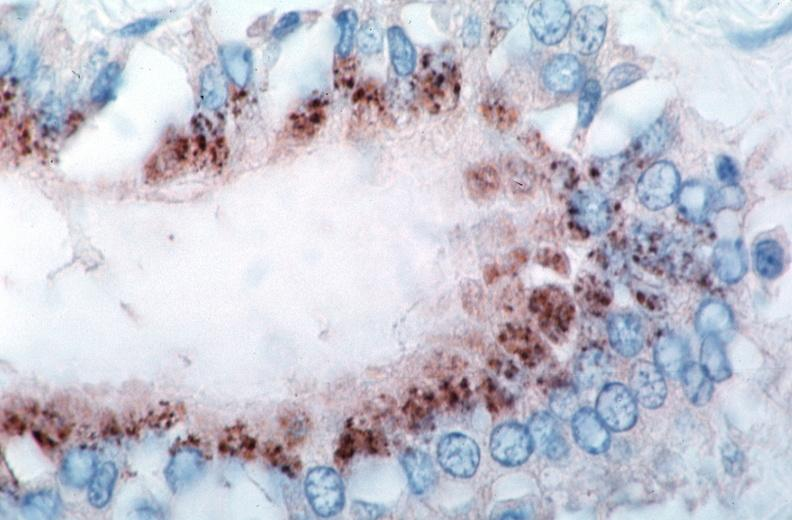what is present?
Answer the question using a single word or phrase. Vasculature 